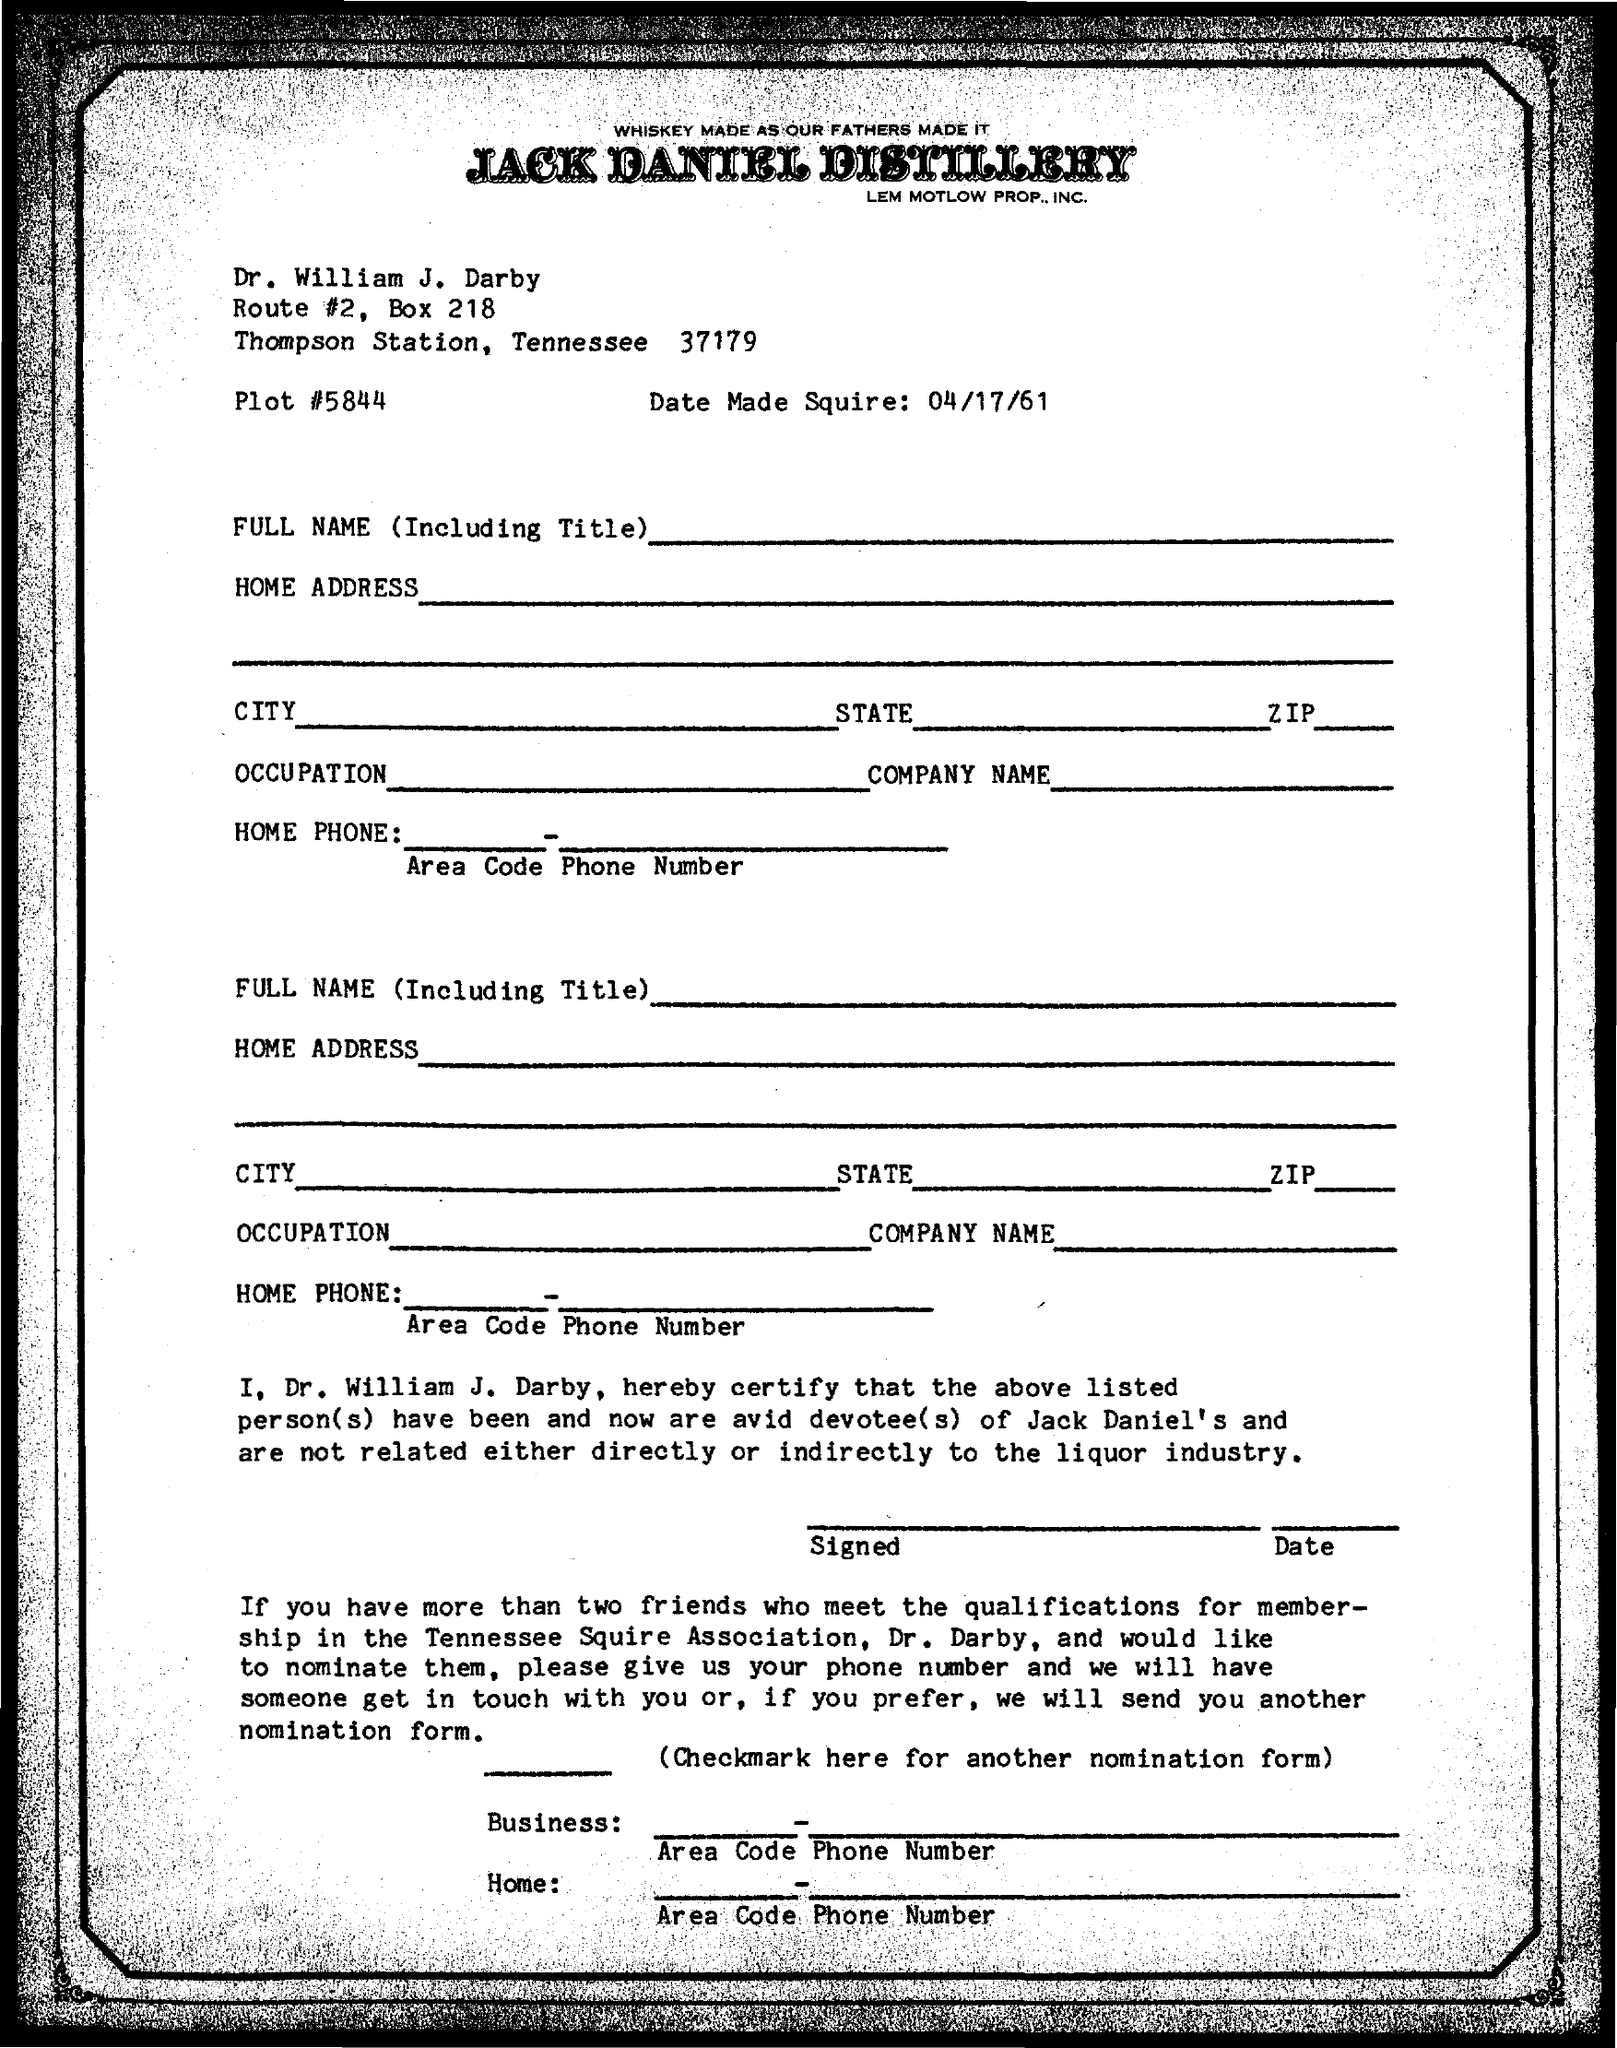What is the Plot #?
Offer a very short reply. 5844. What is the Date made Squire?
Your answer should be very brief. 04/17/61. To Whom is this letter addressed to?
Offer a terse response. Dr. William J. Darby. The notepad is from which company?
Provide a succinct answer. Jack Daniel Distillery. 